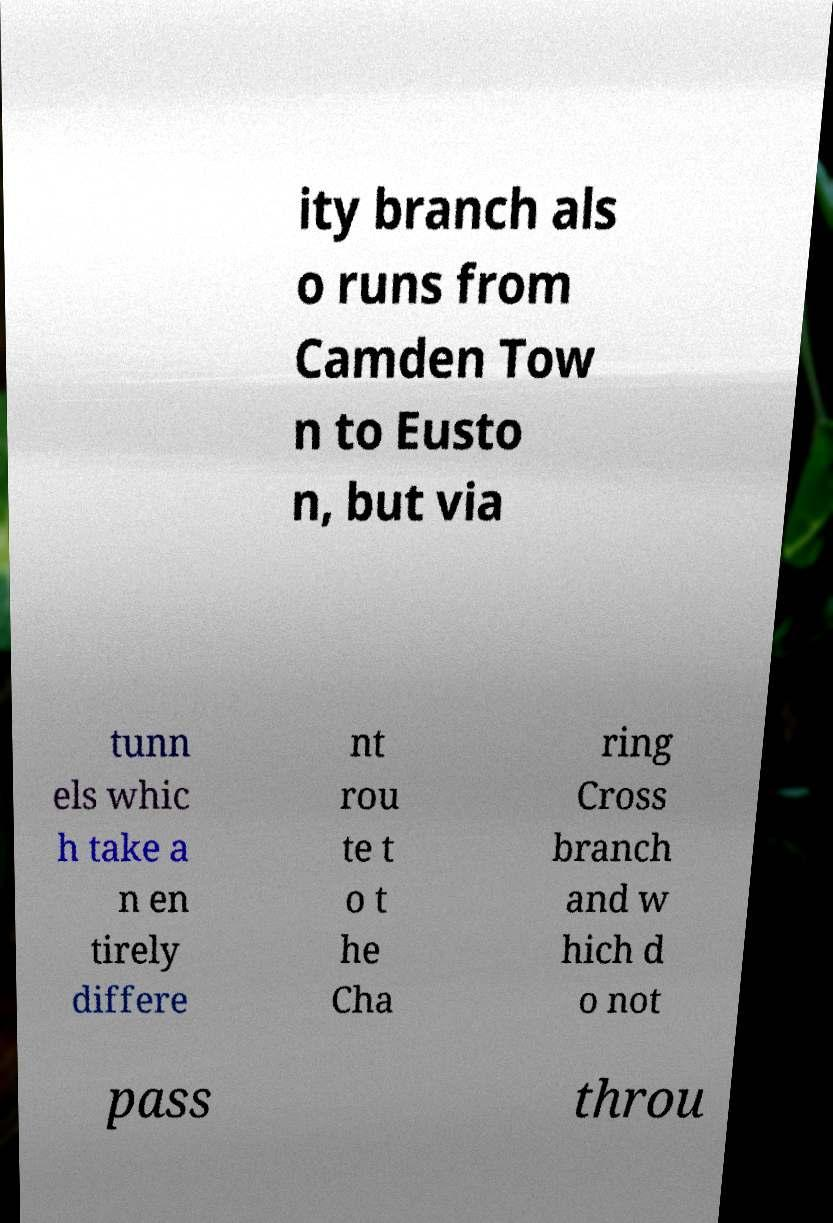Please identify and transcribe the text found in this image. ity branch als o runs from Camden Tow n to Eusto n, but via tunn els whic h take a n en tirely differe nt rou te t o t he Cha ring Cross branch and w hich d o not pass throu 